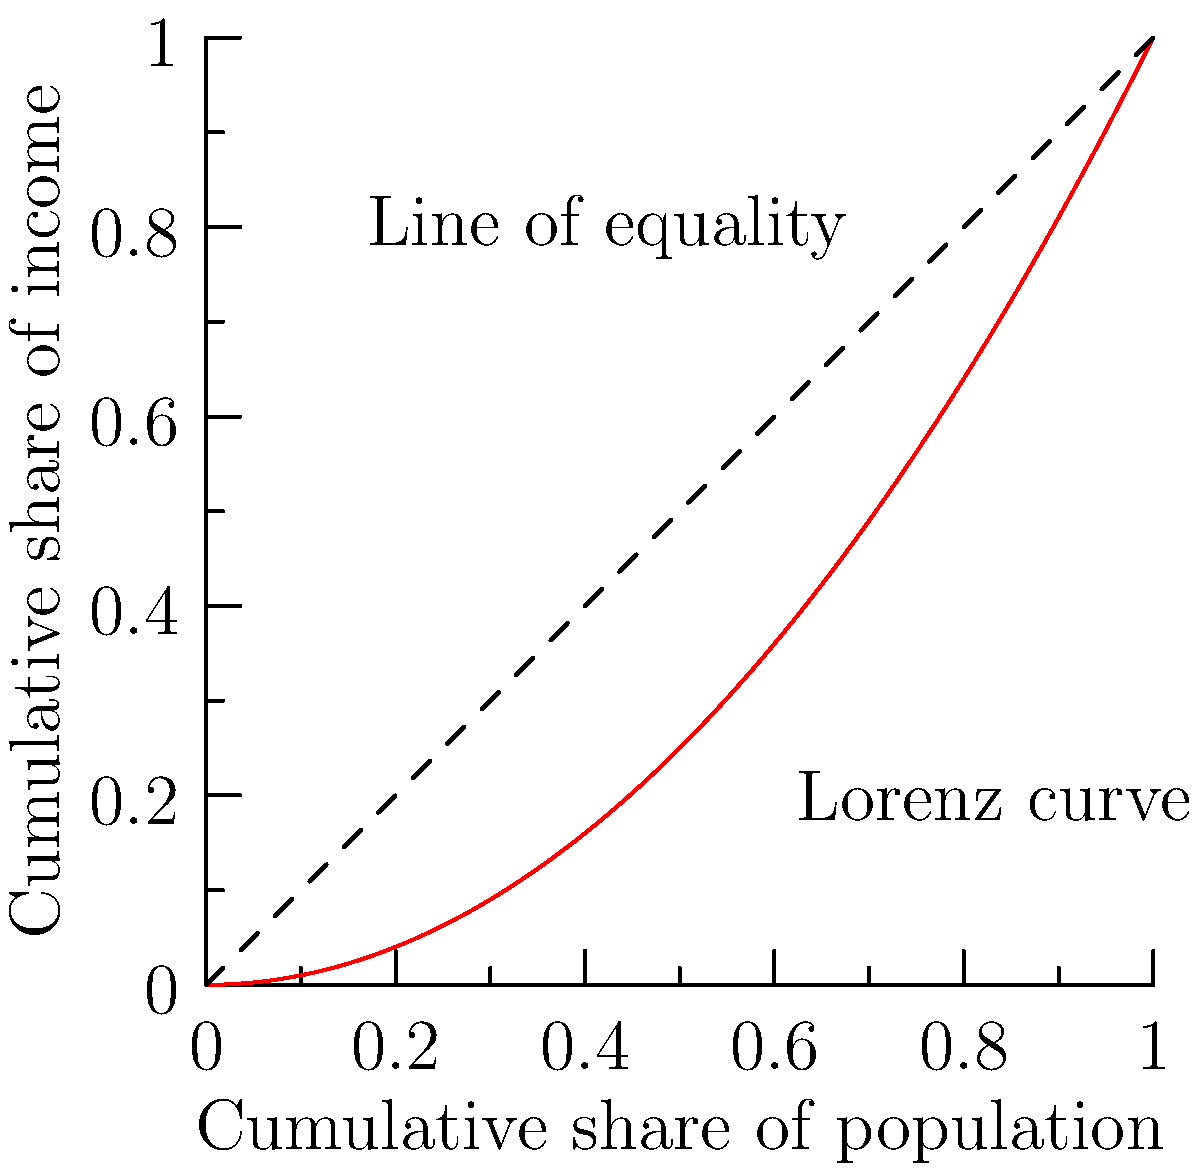As a policy advisor on sustainable development and finance, you are tasked with analyzing income inequality using the Lorenz curve. Given the Lorenz curve function $L(x) = x^2$, where $x$ represents the cumulative share of the population and $L(x)$ represents the cumulative share of income, calculate the Gini coefficient. How would you interpret this result in terms of income inequality? To calculate the Gini coefficient using the Lorenz curve, we follow these steps:

1) The Gini coefficient is defined as the ratio of the area between the line of equality and the Lorenz curve to the total area under the line of equality.

2) The area under the line of equality (a 45-degree line) is always 0.5.

3) To find the area under the Lorenz curve, we integrate the function from 0 to 1:

   $$\int_0^1 L(x) dx = \int_0^1 x^2 dx = [\frac{1}{3}x^3]_0^1 = \frac{1}{3}$$

4) The area between the line of equality and the Lorenz curve is:

   $$0.5 - \frac{1}{3} = \frac{1}{6}$$

5) The Gini coefficient is thus:

   $$G = \frac{\text{Area between line of equality and Lorenz curve}}{\text{Area under line of equality}} = \frac{1/6}{1/2} = \frac{1}{3}$$

Interpretation: The Gini coefficient ranges from 0 (perfect equality) to 1 (perfect inequality). A Gini coefficient of $\frac{1}{3}$ (or about 0.33) indicates a moderate level of income inequality. This suggests that while there is some disparity in income distribution, it is not extreme. As a policy advisor, you might recommend measures to reduce this inequality further, but also note that some level of inequality is typical in most economies.
Answer: Gini coefficient = $\frac{1}{3}$, indicating moderate income inequality. 